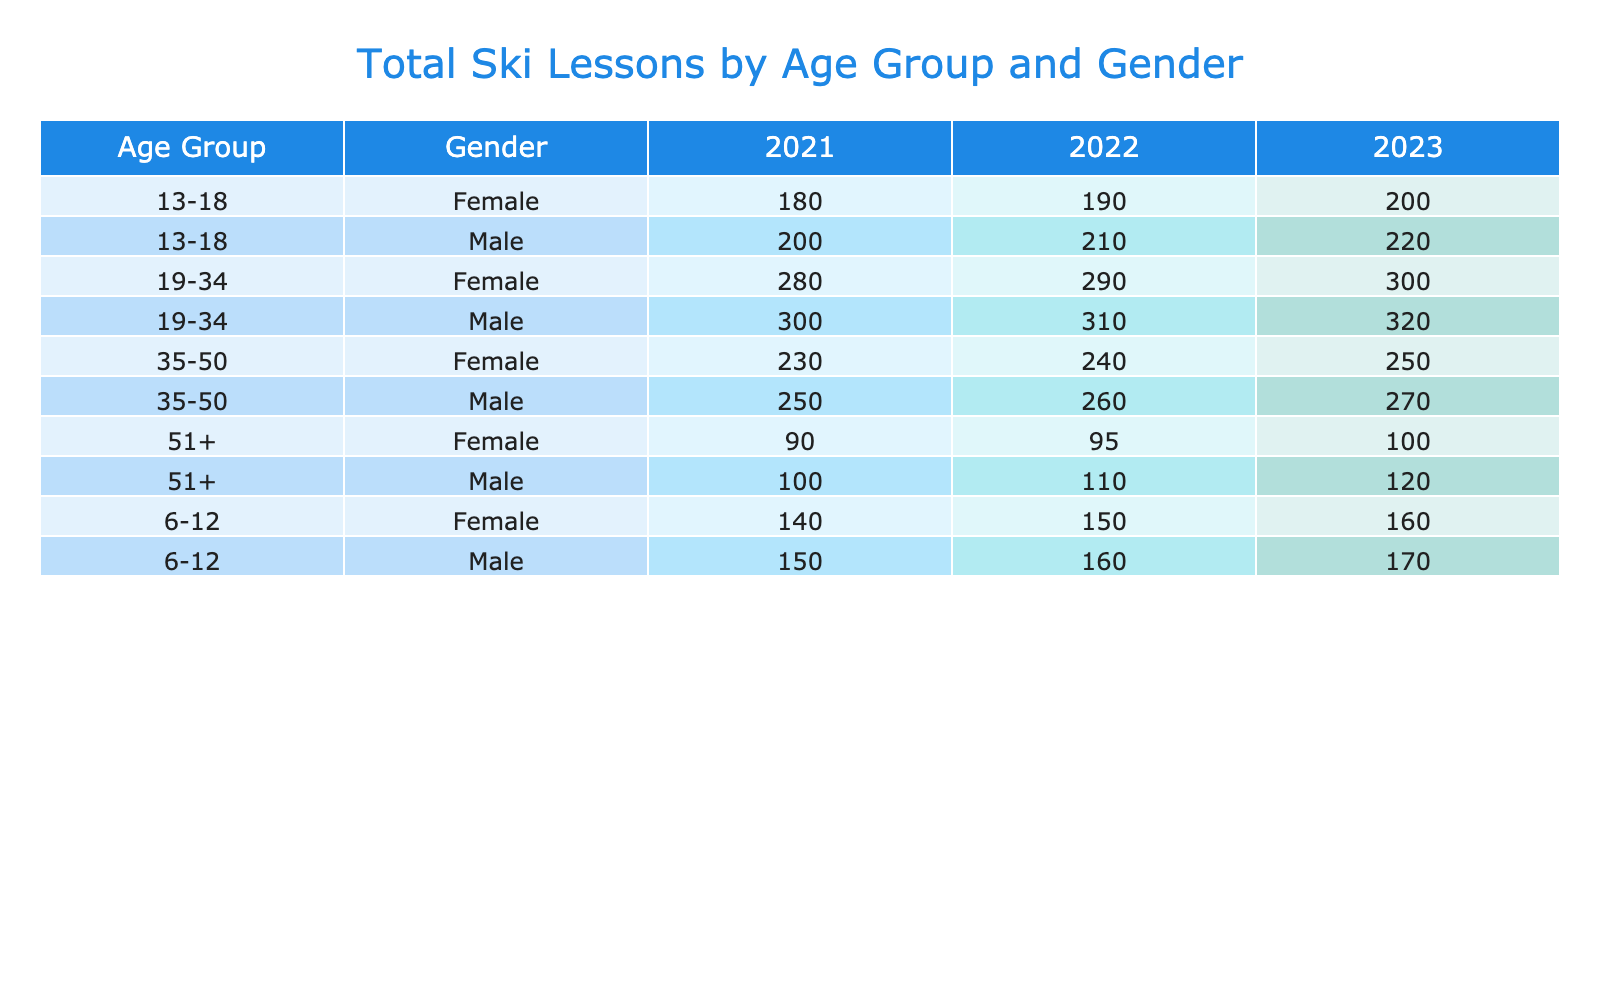What was the total ski lesson attendance for females aged 19-34 in 2022? In the table, the total for females aged 19-34 in 2022 is listed as 290.
Answer: 290 How many total ski lessons were taken by males aged 51+ across all years? By adding the totals for males aged 51+ from each year: 100 + 110 + 120 = 330.
Answer: 330 Did more beginner lessons take place for the 6-12 age group compared to the 19-34 age group in 2023? In 2023, there were 100 beginner lessons for the 6-12 age group and 50 for the 19-34 age group; therefore, there were more for 6-12.
Answer: Yes What is the difference in total ski lessons between males aged 35-50 in 2022 and 2023? For males aged 35-50, the total in 2022 is 260 and in 2023 is 270. The difference is 270 - 260 = 10.
Answer: 10 Which age group had the highest total ski lessons for females in 2021? Scanning the table for females in 2021: 6-12 had 140, 13-18 had 180, 19-34 had 280, 35-50 had 230, and 51+ had 90, so 19-34 had the highest.
Answer: 19-34 Calculate the average number of private lessons taken by males in the 13-18 age group across all years. The totals for private lessons for males aged 13-18 are 50 (2021) + 55 (2022) + 60 (2023) = 165. There are 3 years, so the average is 165 / 3 = 55.
Answer: 55 Was there an increase in total ski lessons for females in the 6-12 age group from 2021 to 2022? In 2021, females aged 6-12 had 140 total ski lessons, and in 2022, they had 150, indicating an increase of 10.
Answer: Yes What percentage of total ski lessons for males aged 19-34 in 2023 were advanced lessons? The total for males aged 19-34 in 2023 is 320, and the advanced lessons are 150. So, percentage = (150 / 320) * 100 = 46.875%.
Answer: 46.88% How many total lessons were taken by females aged 35-50 compared to males of the same age group across all years? Totals for females aged 35-50: 230 (2021) + 240 (2022) + 250 (2023) = 720. For males: 250 + 260 + 270 = 780. Males had more lessons.
Answer: Males had more lessons What is the trend in total ski lesson attendance for males aged 6-12 from 2021 to 2023? The total for 2021 is 150, for 2022 is 160, and for 2023 is 170, showing a consistent increase each year.
Answer: Increasing trend 